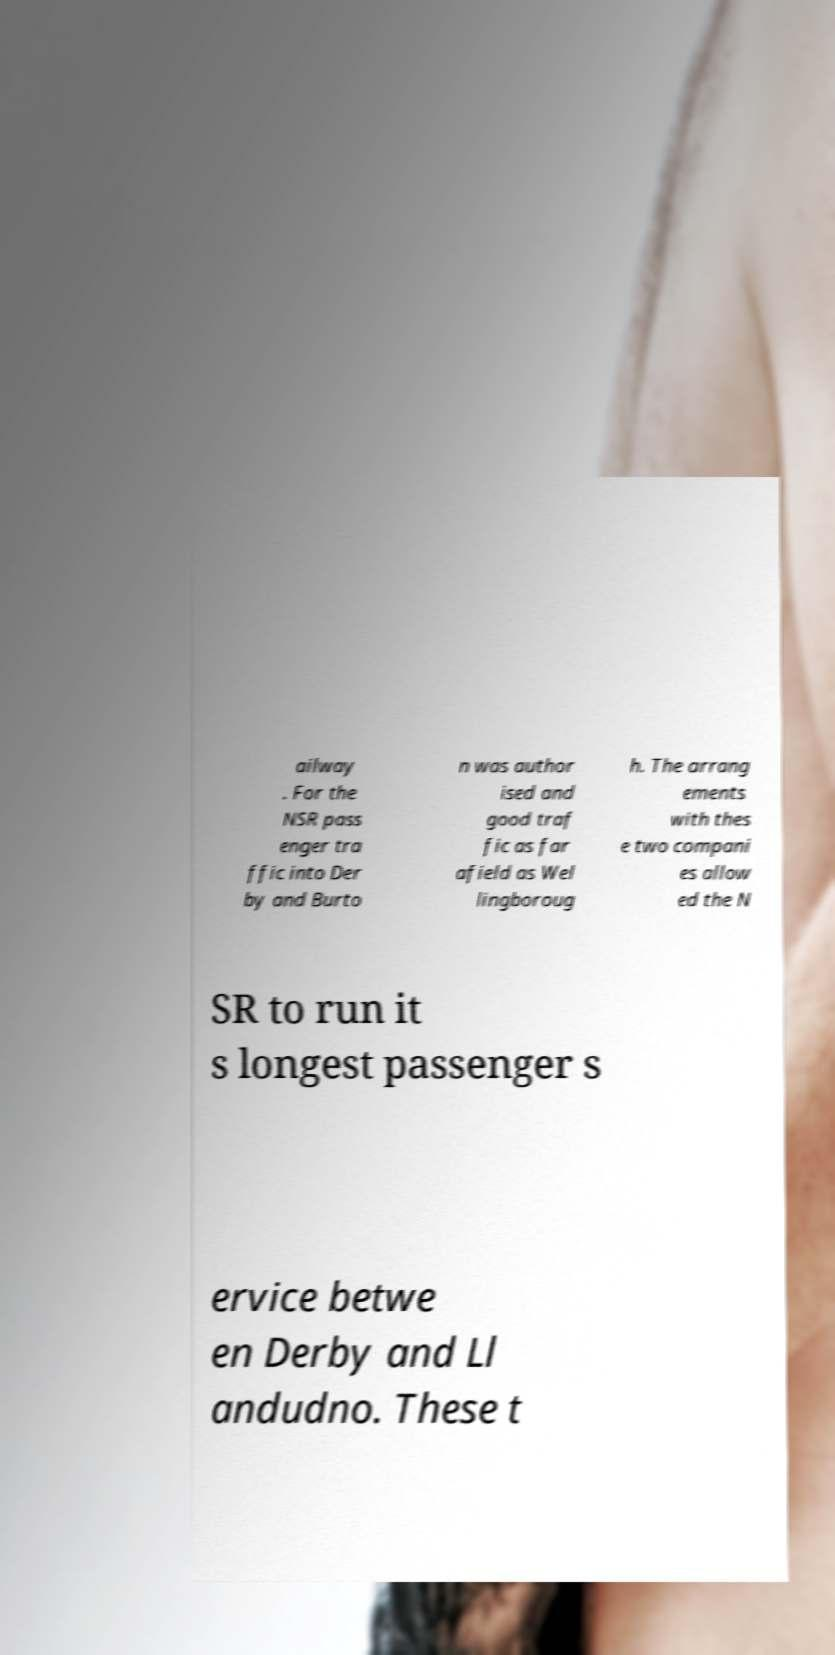There's text embedded in this image that I need extracted. Can you transcribe it verbatim? ailway . For the NSR pass enger tra ffic into Der by and Burto n was author ised and good traf fic as far afield as Wel lingboroug h. The arrang ements with thes e two compani es allow ed the N SR to run it s longest passenger s ervice betwe en Derby and Ll andudno. These t 